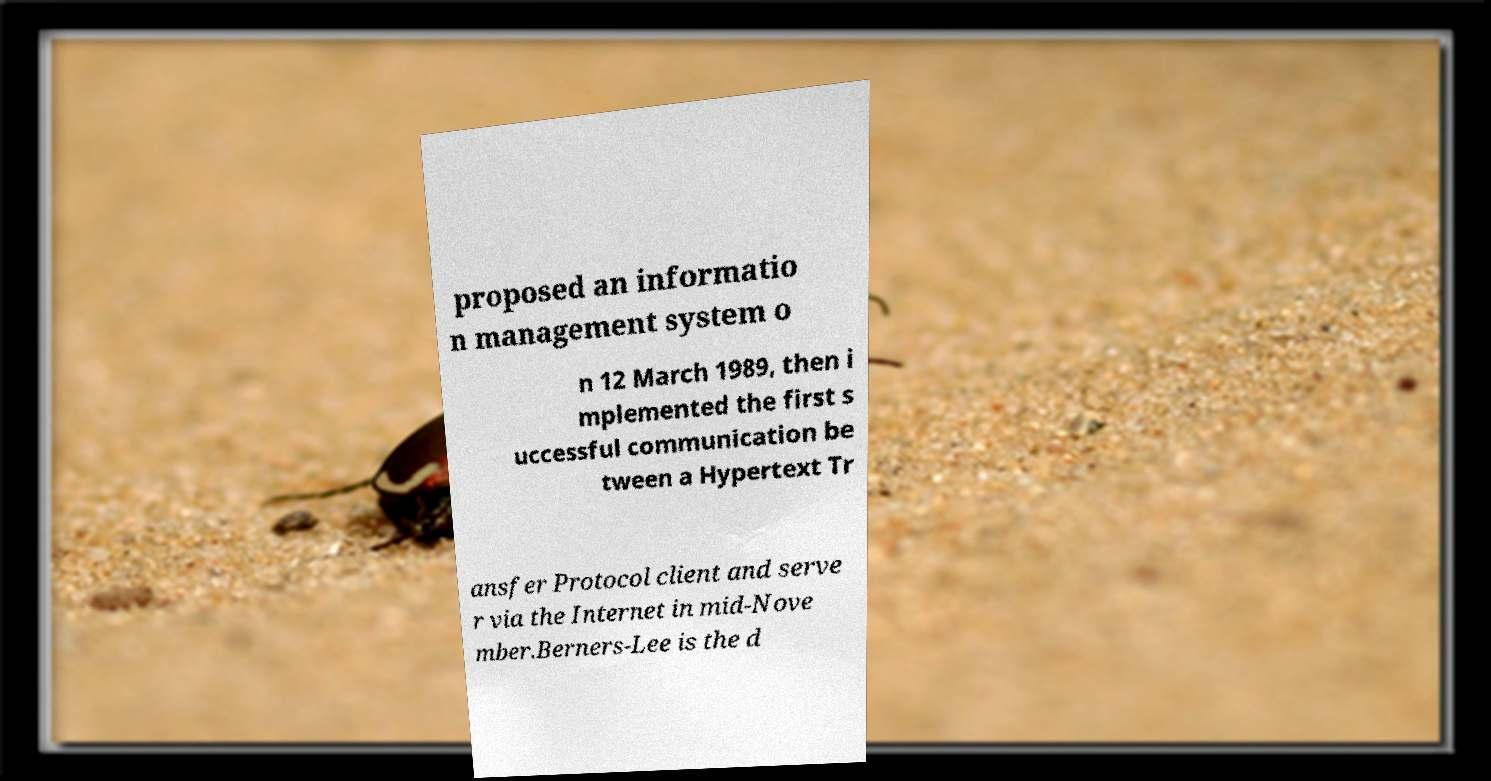There's text embedded in this image that I need extracted. Can you transcribe it verbatim? proposed an informatio n management system o n 12 March 1989, then i mplemented the first s uccessful communication be tween a Hypertext Tr ansfer Protocol client and serve r via the Internet in mid-Nove mber.Berners-Lee is the d 